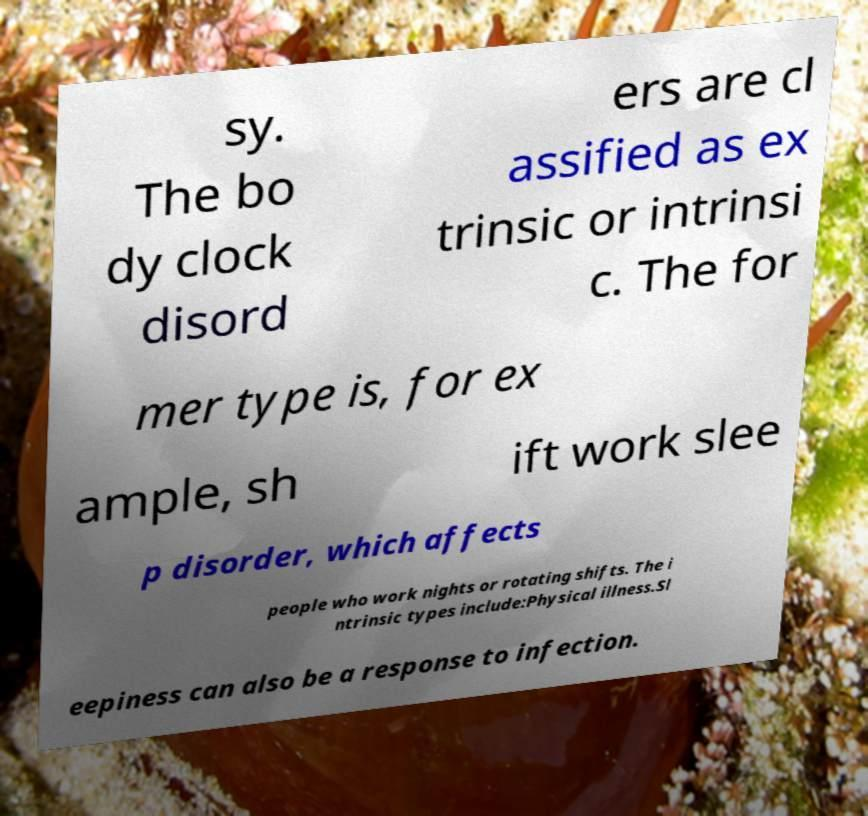What messages or text are displayed in this image? I need them in a readable, typed format. sy. The bo dy clock disord ers are cl assified as ex trinsic or intrinsi c. The for mer type is, for ex ample, sh ift work slee p disorder, which affects people who work nights or rotating shifts. The i ntrinsic types include:Physical illness.Sl eepiness can also be a response to infection. 